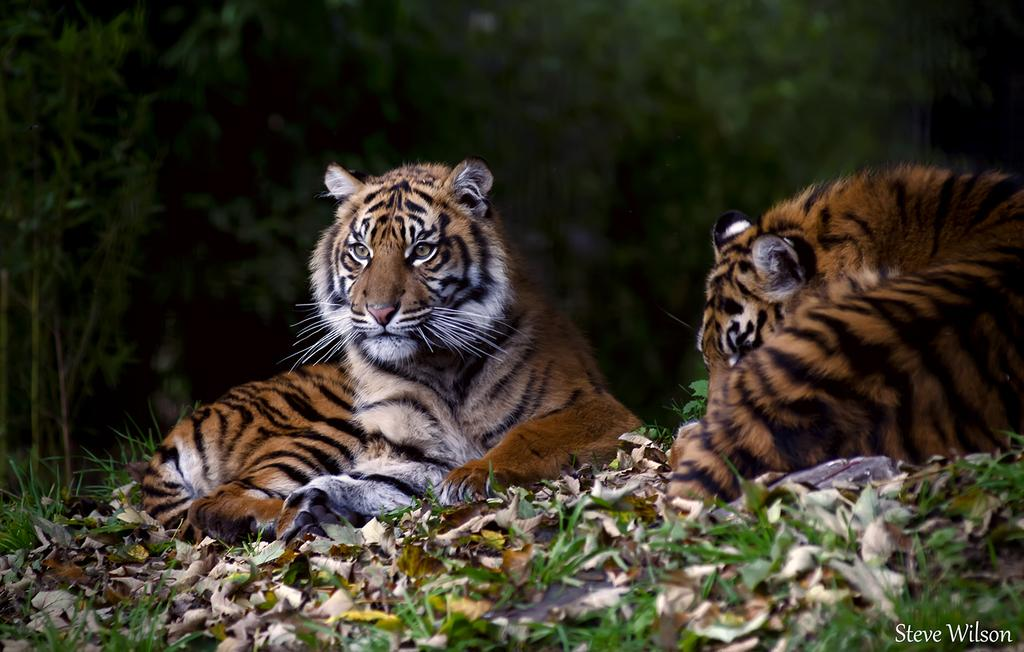How many tigers are in the image? There are two tigers in the image. What is on the ground can be seen beneath the tigers? There are dry leaves and grass on the ground. What is visible in the background of the image? There are trees in the background of the image. What is the opinion of the tigers about the protest happening in the city? There is no protest mentioned in the image, and the tigers' opinions cannot be determined as they are animals and do not have opinions. 